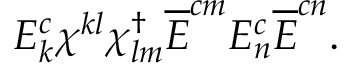<formula> <loc_0><loc_0><loc_500><loc_500>E _ { k } ^ { c } \chi ^ { k l } \chi _ { l m } ^ { \dagger } \overline { E } ^ { c m } E _ { n } ^ { c } \overline { E } ^ { c n } .</formula> 